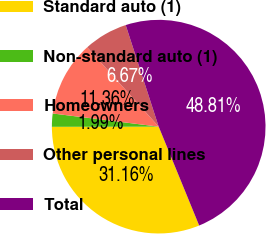Convert chart to OTSL. <chart><loc_0><loc_0><loc_500><loc_500><pie_chart><fcel>Standard auto (1)<fcel>Non-standard auto (1)<fcel>Homeowners<fcel>Other personal lines<fcel>Total<nl><fcel>31.16%<fcel>1.99%<fcel>11.36%<fcel>6.67%<fcel>48.81%<nl></chart> 